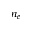Convert formula to latex. <formula><loc_0><loc_0><loc_500><loc_500>n _ { e }</formula> 